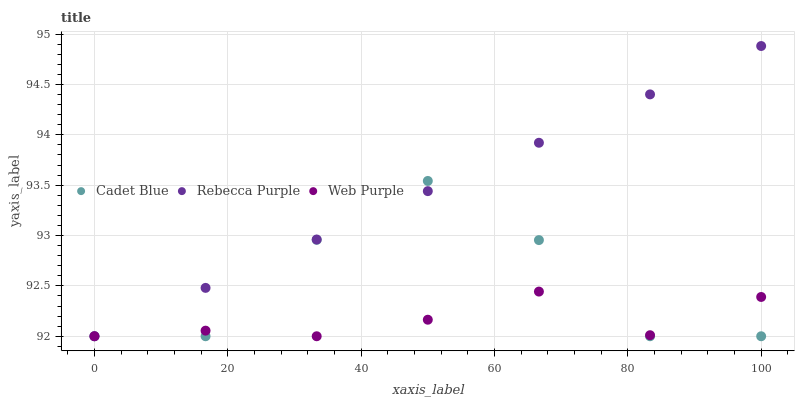Does Web Purple have the minimum area under the curve?
Answer yes or no. Yes. Does Rebecca Purple have the maximum area under the curve?
Answer yes or no. Yes. Does Cadet Blue have the minimum area under the curve?
Answer yes or no. No. Does Cadet Blue have the maximum area under the curve?
Answer yes or no. No. Is Rebecca Purple the smoothest?
Answer yes or no. Yes. Is Cadet Blue the roughest?
Answer yes or no. Yes. Is Cadet Blue the smoothest?
Answer yes or no. No. Is Rebecca Purple the roughest?
Answer yes or no. No. Does Web Purple have the lowest value?
Answer yes or no. Yes. Does Rebecca Purple have the highest value?
Answer yes or no. Yes. Does Cadet Blue have the highest value?
Answer yes or no. No. Does Cadet Blue intersect Rebecca Purple?
Answer yes or no. Yes. Is Cadet Blue less than Rebecca Purple?
Answer yes or no. No. Is Cadet Blue greater than Rebecca Purple?
Answer yes or no. No. 